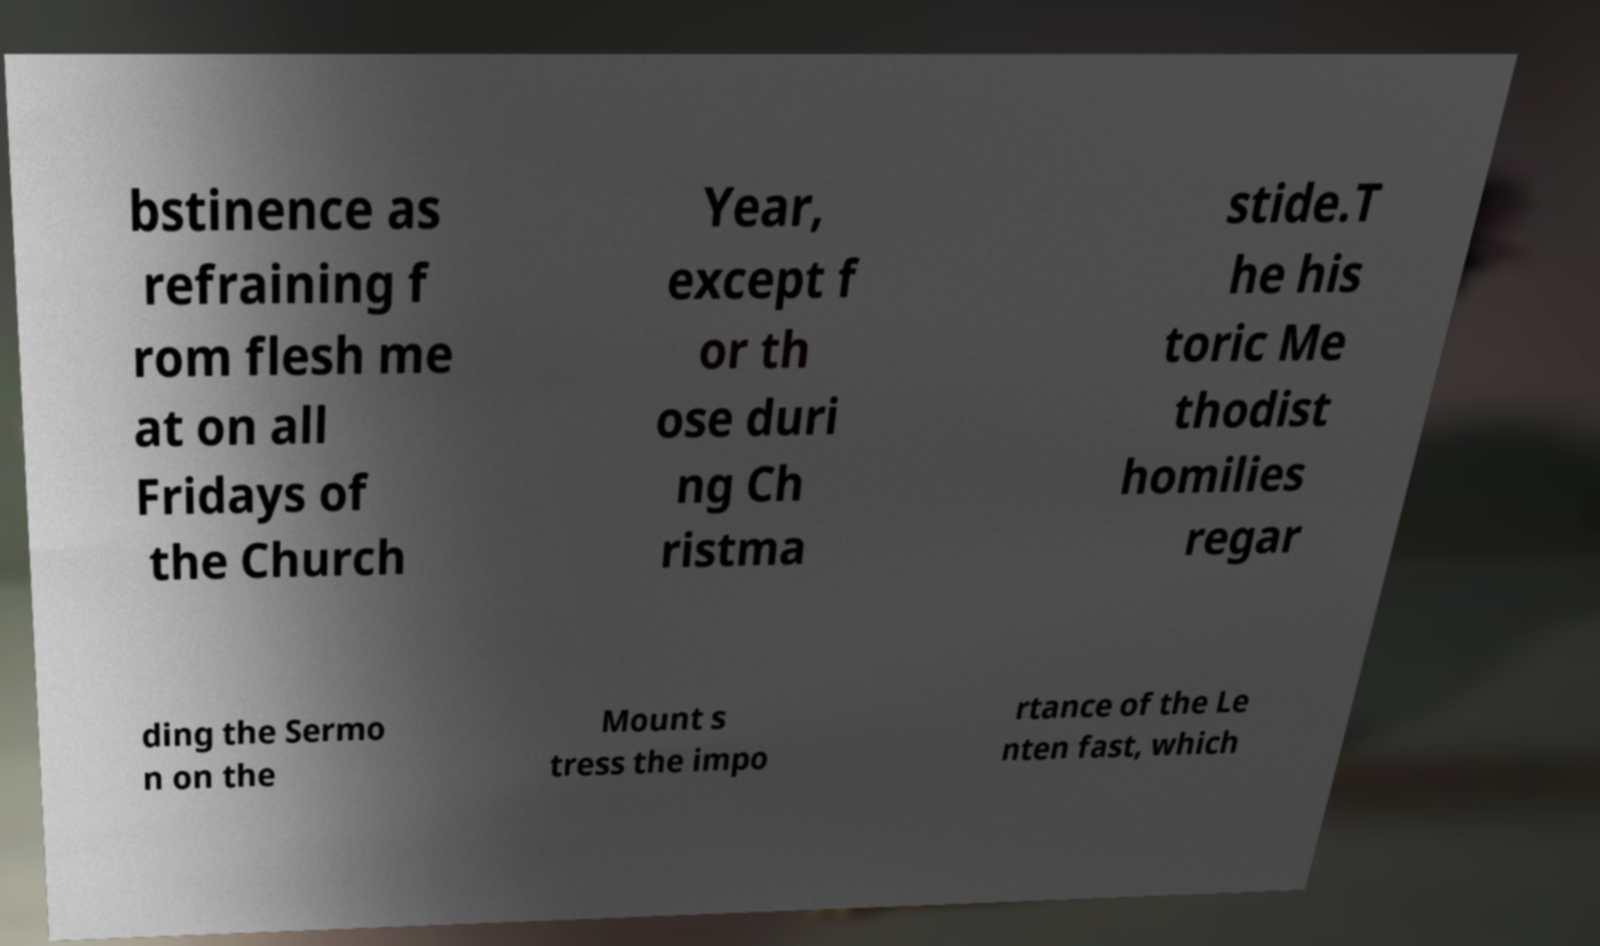Could you assist in decoding the text presented in this image and type it out clearly? bstinence as refraining f rom flesh me at on all Fridays of the Church Year, except f or th ose duri ng Ch ristma stide.T he his toric Me thodist homilies regar ding the Sermo n on the Mount s tress the impo rtance of the Le nten fast, which 